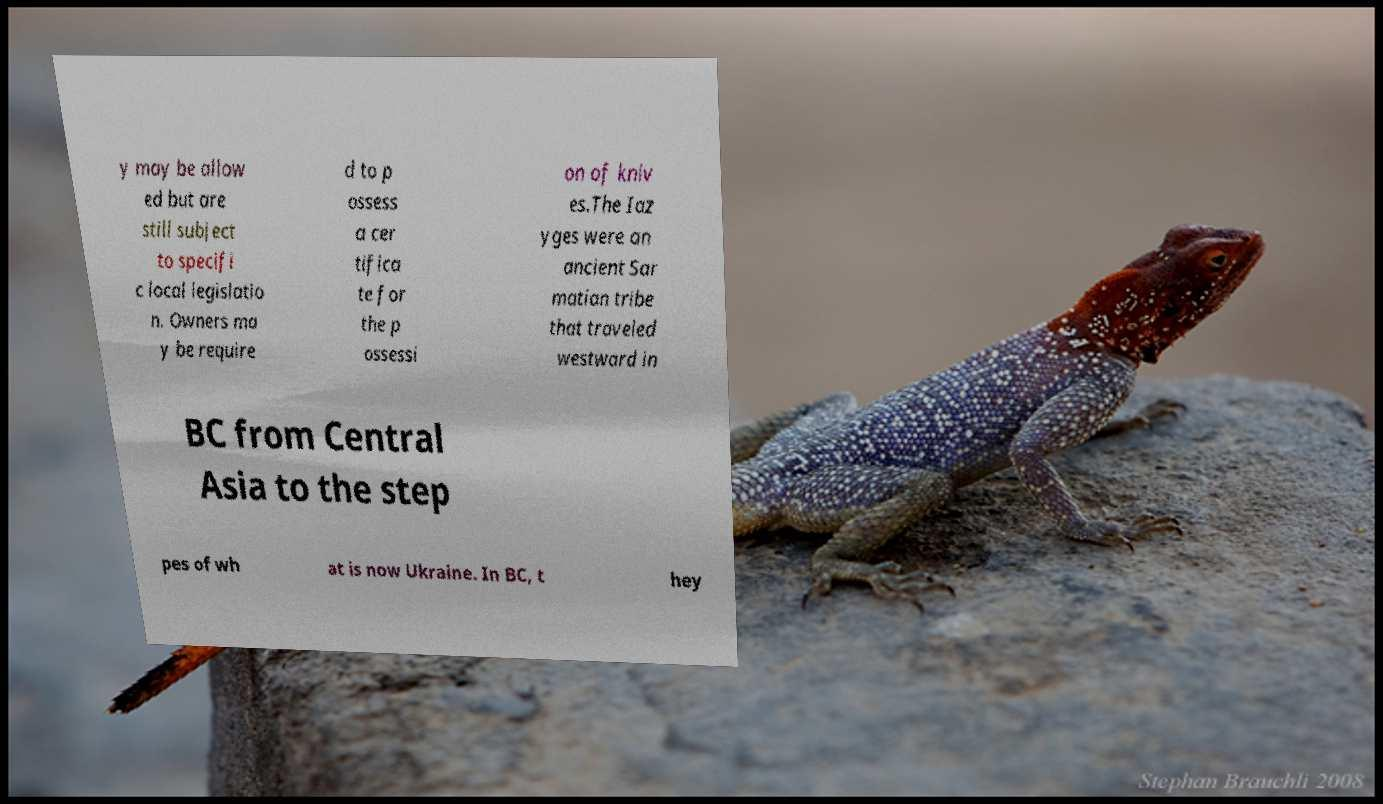Please read and relay the text visible in this image. What does it say? y may be allow ed but are still subject to specifi c local legislatio n. Owners ma y be require d to p ossess a cer tifica te for the p ossessi on of kniv es.The Iaz yges were an ancient Sar matian tribe that traveled westward in BC from Central Asia to the step pes of wh at is now Ukraine. In BC, t hey 